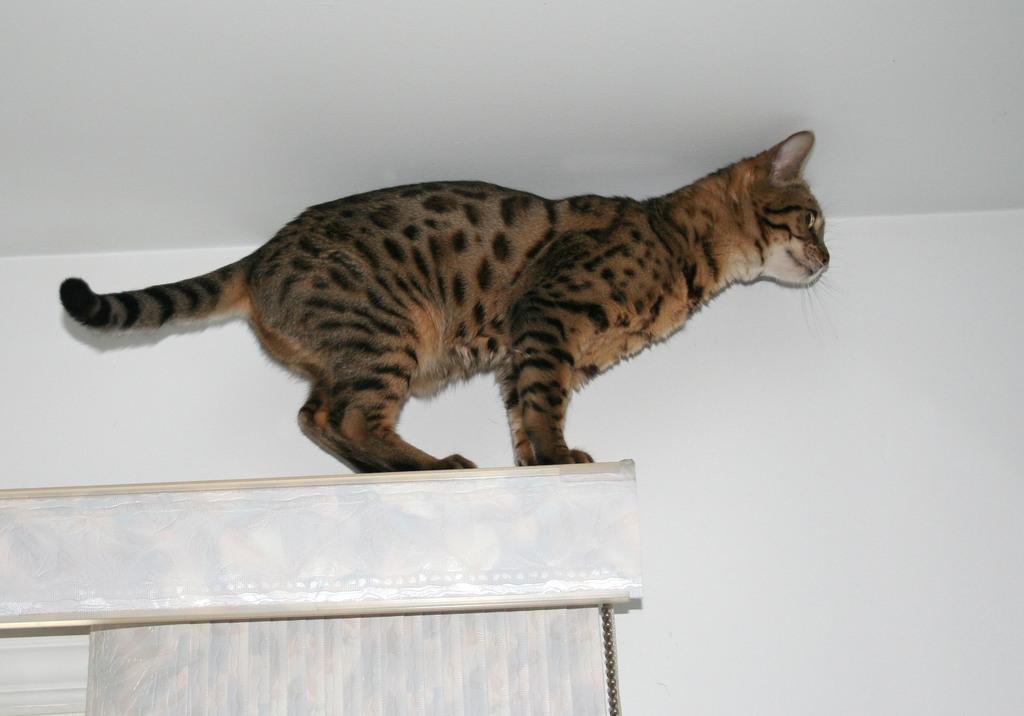How would you summarize this image in a sentence or two? In this image I can see a cat, window, blind and wall. This image is taken may be in a room. 